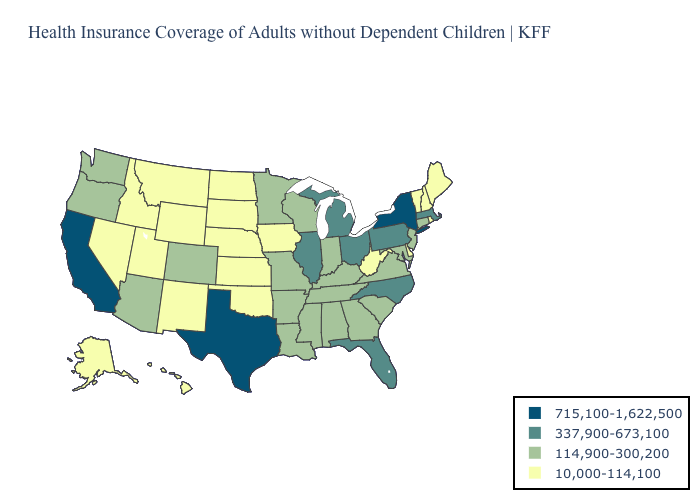What is the value of Oregon?
Keep it brief. 114,900-300,200. What is the value of South Carolina?
Quick response, please. 114,900-300,200. Is the legend a continuous bar?
Answer briefly. No. Among the states that border Illinois , does Iowa have the highest value?
Answer briefly. No. Does Illinois have a lower value than New York?
Short answer required. Yes. What is the value of Idaho?
Write a very short answer. 10,000-114,100. How many symbols are there in the legend?
Quick response, please. 4. Which states have the lowest value in the USA?
Give a very brief answer. Alaska, Delaware, Hawaii, Idaho, Iowa, Kansas, Maine, Montana, Nebraska, Nevada, New Hampshire, New Mexico, North Dakota, Oklahoma, Rhode Island, South Dakota, Utah, Vermont, West Virginia, Wyoming. Which states have the highest value in the USA?
Keep it brief. California, New York, Texas. Among the states that border Arkansas , which have the highest value?
Short answer required. Texas. What is the value of Oklahoma?
Be succinct. 10,000-114,100. Among the states that border West Virginia , which have the highest value?
Write a very short answer. Ohio, Pennsylvania. What is the highest value in the South ?
Keep it brief. 715,100-1,622,500. What is the value of Kentucky?
Answer briefly. 114,900-300,200. Among the states that border Pennsylvania , does Ohio have the highest value?
Keep it brief. No. 